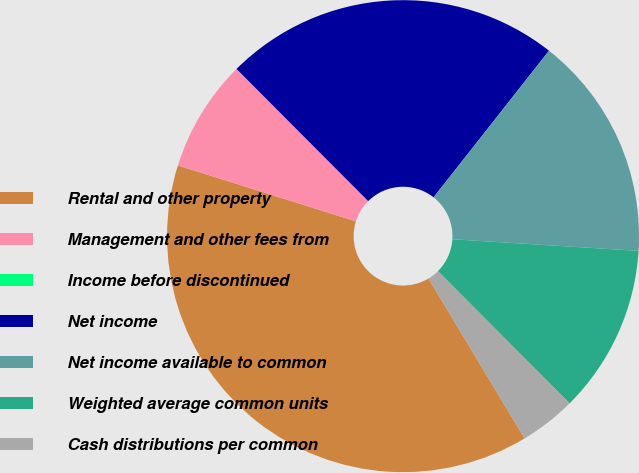<chart> <loc_0><loc_0><loc_500><loc_500><pie_chart><fcel>Rental and other property<fcel>Management and other fees from<fcel>Income before discontinued<fcel>Net income<fcel>Net income available to common<fcel>Weighted average common units<fcel>Cash distributions per common<nl><fcel>38.46%<fcel>7.69%<fcel>0.0%<fcel>23.08%<fcel>15.38%<fcel>11.54%<fcel>3.85%<nl></chart> 